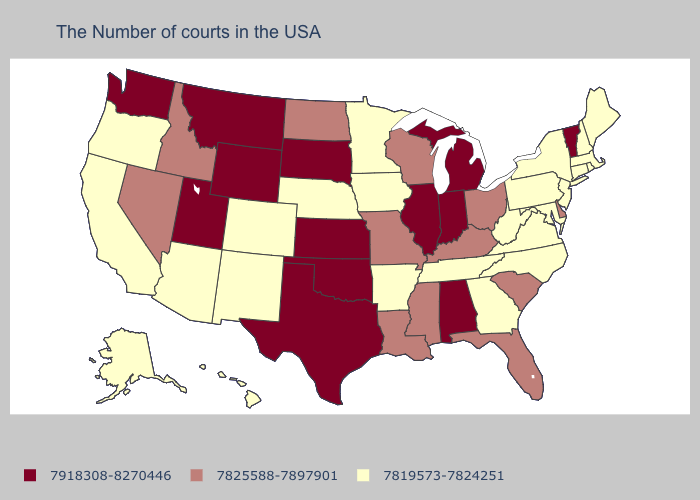What is the value of Alaska?
Write a very short answer. 7819573-7824251. Does Alabama have the highest value in the USA?
Be succinct. Yes. What is the highest value in the MidWest ?
Be succinct. 7918308-8270446. Name the states that have a value in the range 7819573-7824251?
Answer briefly. Maine, Massachusetts, Rhode Island, New Hampshire, Connecticut, New York, New Jersey, Maryland, Pennsylvania, Virginia, North Carolina, West Virginia, Georgia, Tennessee, Arkansas, Minnesota, Iowa, Nebraska, Colorado, New Mexico, Arizona, California, Oregon, Alaska, Hawaii. Name the states that have a value in the range 7918308-8270446?
Concise answer only. Vermont, Michigan, Indiana, Alabama, Illinois, Kansas, Oklahoma, Texas, South Dakota, Wyoming, Utah, Montana, Washington. Among the states that border Utah , does Idaho have the lowest value?
Give a very brief answer. No. Name the states that have a value in the range 7918308-8270446?
Give a very brief answer. Vermont, Michigan, Indiana, Alabama, Illinois, Kansas, Oklahoma, Texas, South Dakota, Wyoming, Utah, Montana, Washington. What is the lowest value in the Northeast?
Concise answer only. 7819573-7824251. Does the first symbol in the legend represent the smallest category?
Keep it brief. No. What is the value of Vermont?
Answer briefly. 7918308-8270446. Name the states that have a value in the range 7819573-7824251?
Short answer required. Maine, Massachusetts, Rhode Island, New Hampshire, Connecticut, New York, New Jersey, Maryland, Pennsylvania, Virginia, North Carolina, West Virginia, Georgia, Tennessee, Arkansas, Minnesota, Iowa, Nebraska, Colorado, New Mexico, Arizona, California, Oregon, Alaska, Hawaii. Which states have the lowest value in the USA?
Be succinct. Maine, Massachusetts, Rhode Island, New Hampshire, Connecticut, New York, New Jersey, Maryland, Pennsylvania, Virginia, North Carolina, West Virginia, Georgia, Tennessee, Arkansas, Minnesota, Iowa, Nebraska, Colorado, New Mexico, Arizona, California, Oregon, Alaska, Hawaii. Name the states that have a value in the range 7819573-7824251?
Concise answer only. Maine, Massachusetts, Rhode Island, New Hampshire, Connecticut, New York, New Jersey, Maryland, Pennsylvania, Virginia, North Carolina, West Virginia, Georgia, Tennessee, Arkansas, Minnesota, Iowa, Nebraska, Colorado, New Mexico, Arizona, California, Oregon, Alaska, Hawaii. What is the value of Wyoming?
Write a very short answer. 7918308-8270446. 